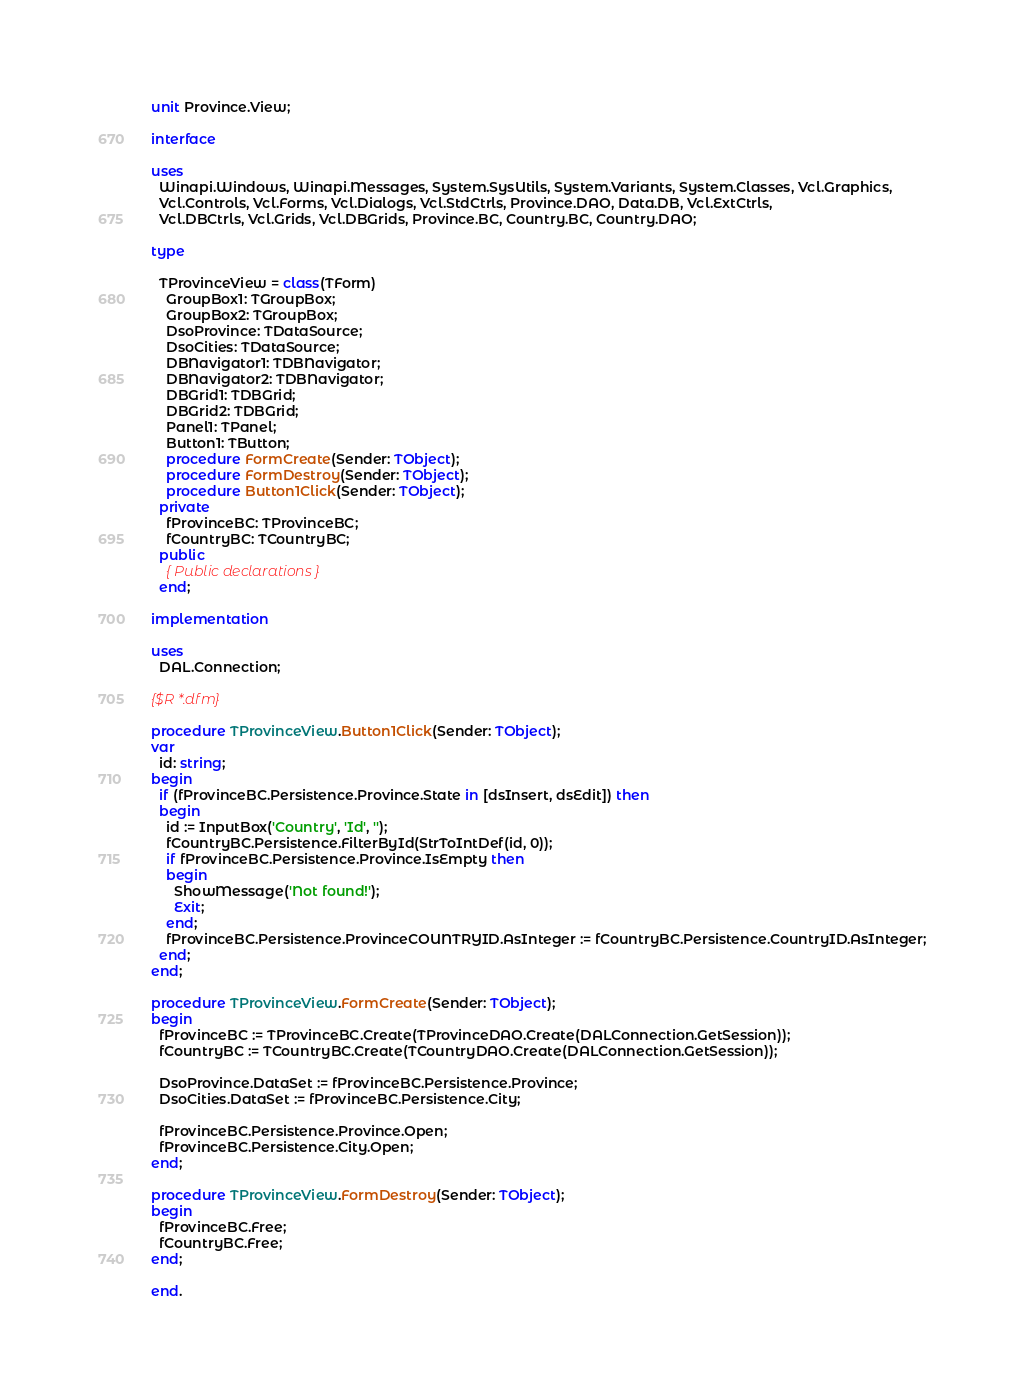Convert code to text. <code><loc_0><loc_0><loc_500><loc_500><_Pascal_>unit Province.View;

interface

uses
  Winapi.Windows, Winapi.Messages, System.SysUtils, System.Variants, System.Classes, Vcl.Graphics,
  Vcl.Controls, Vcl.Forms, Vcl.Dialogs, Vcl.StdCtrls, Province.DAO, Data.DB, Vcl.ExtCtrls,
  Vcl.DBCtrls, Vcl.Grids, Vcl.DBGrids, Province.BC, Country.BC, Country.DAO;

type

  TProvinceView = class(TForm)
    GroupBox1: TGroupBox;
    GroupBox2: TGroupBox;
    DsoProvince: TDataSource;
    DsoCities: TDataSource;
    DBNavigator1: TDBNavigator;
    DBNavigator2: TDBNavigator;
    DBGrid1: TDBGrid;
    DBGrid2: TDBGrid;
    Panel1: TPanel;
    Button1: TButton;
    procedure FormCreate(Sender: TObject);
    procedure FormDestroy(Sender: TObject);
    procedure Button1Click(Sender: TObject);
  private
    fProvinceBC: TProvinceBC;
    fCountryBC: TCountryBC;
  public
    { Public declarations }
  end;

implementation

uses
  DAL.Connection;

{$R *.dfm}

procedure TProvinceView.Button1Click(Sender: TObject);
var
  id: string;
begin
  if (fProvinceBC.Persistence.Province.State in [dsInsert, dsEdit]) then
  begin
    id := InputBox('Country', 'Id', '');
    fCountryBC.Persistence.FilterById(StrToIntDef(id, 0));
    if fProvinceBC.Persistence.Province.IsEmpty then
    begin
      ShowMessage('Not found!');
      Exit;
    end;
    fProvinceBC.Persistence.ProvinceCOUNTRYID.AsInteger := fCountryBC.Persistence.CountryID.AsInteger;
  end;
end;

procedure TProvinceView.FormCreate(Sender: TObject);
begin
  fProvinceBC := TProvinceBC.Create(TProvinceDAO.Create(DALConnection.GetSession));
  fCountryBC := TCountryBC.Create(TCountryDAO.Create(DALConnection.GetSession));

  DsoProvince.DataSet := fProvinceBC.Persistence.Province;
  DsoCities.DataSet := fProvinceBC.Persistence.City;

  fProvinceBC.Persistence.Province.Open;
  fProvinceBC.Persistence.City.Open;
end;

procedure TProvinceView.FormDestroy(Sender: TObject);
begin
  fProvinceBC.Free;
  fCountryBC.Free;
end;

end.
</code> 